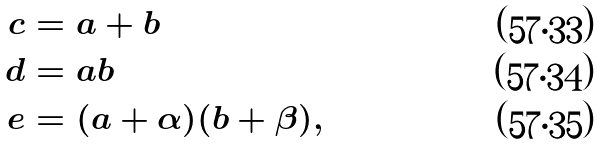Convert formula to latex. <formula><loc_0><loc_0><loc_500><loc_500>c & = a + b \\ d & = a b \\ e & = ( a + \alpha ) ( b + \beta ) ,</formula> 